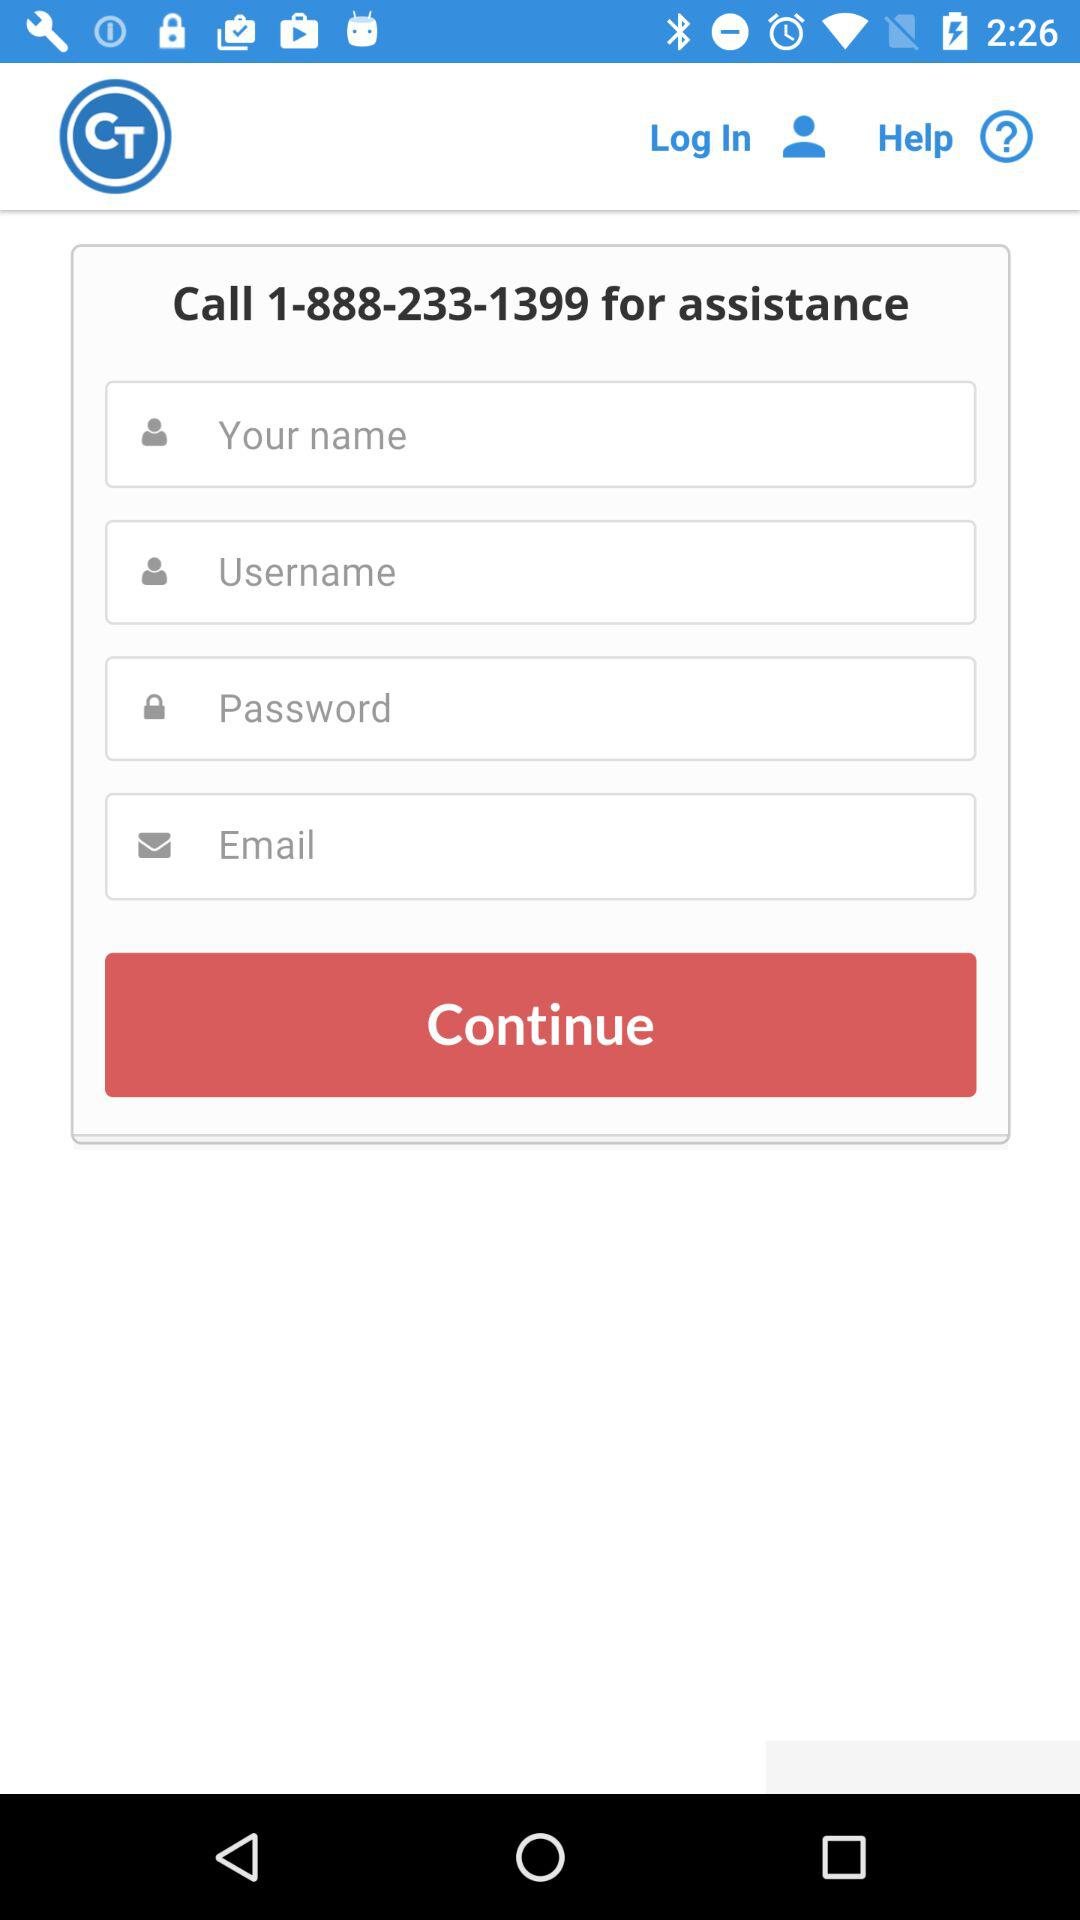What is the calling number for assistance? The calling number for assistance is 1-888-233-1399. 